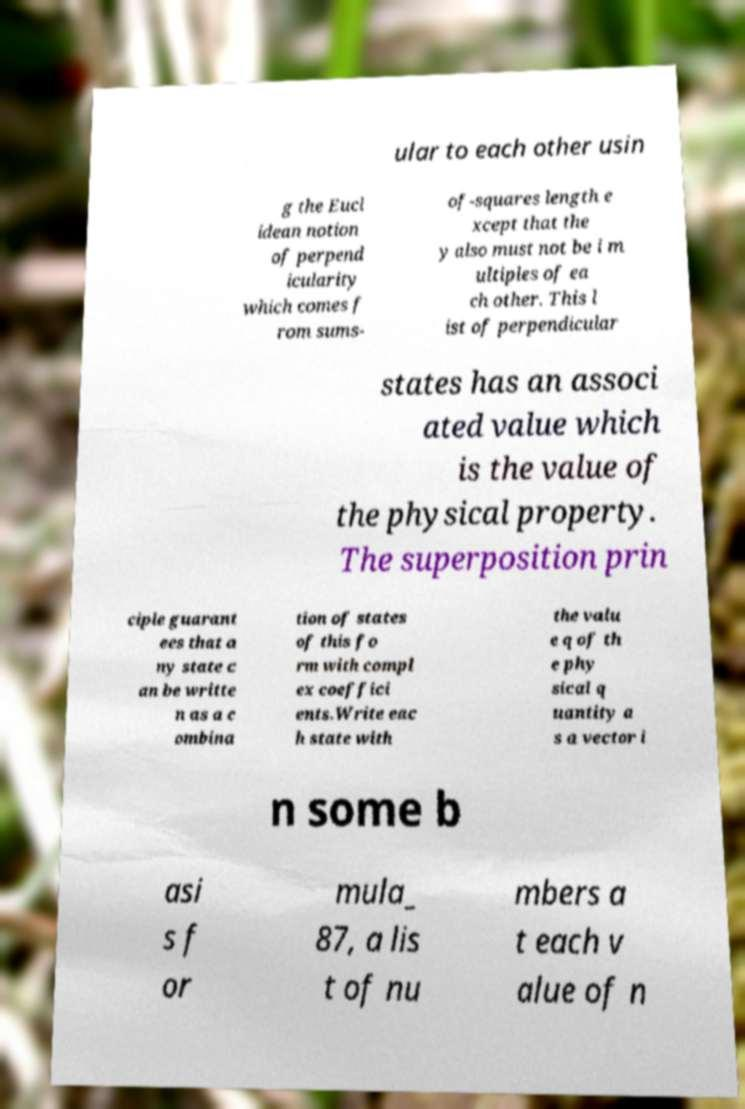Please identify and transcribe the text found in this image. ular to each other usin g the Eucl idean notion of perpend icularity which comes f rom sums- of-squares length e xcept that the y also must not be i m ultiples of ea ch other. This l ist of perpendicular states has an associ ated value which is the value of the physical property. The superposition prin ciple guarant ees that a ny state c an be writte n as a c ombina tion of states of this fo rm with compl ex coeffici ents.Write eac h state with the valu e q of th e phy sical q uantity a s a vector i n some b asi s f or mula_ 87, a lis t of nu mbers a t each v alue of n 